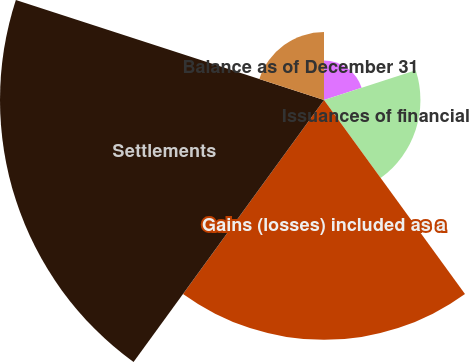Convert chart. <chart><loc_0><loc_0><loc_500><loc_500><pie_chart><fcel>Balance as of January 1<fcel>Issuances of financial<fcel>Gains (losses) included as a<fcel>Settlements<fcel>Balance as of December 31<nl><fcel>5.15%<fcel>12.56%<fcel>31.24%<fcel>42.2%<fcel>8.85%<nl></chart> 